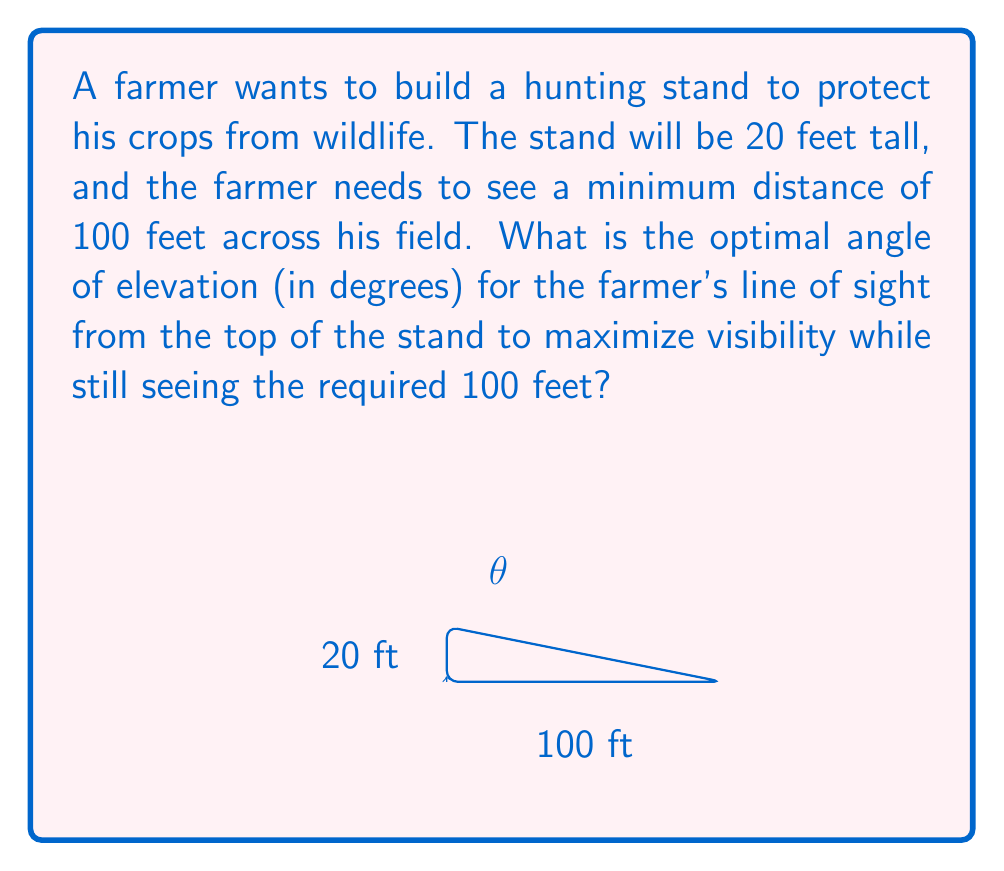Teach me how to tackle this problem. Let's approach this step-by-step:

1) First, we need to understand that the optimal angle of elevation will be the one that allows the farmer to see exactly 100 feet away. Any steeper angle would reduce the visible distance.

2) We can model this situation as a right triangle, where:
   - The vertical side is the height of the stand (20 feet)
   - The horizontal side is the distance to be seen (100 feet)
   - The angle we're looking for is the one between the horizontal and the line of sight

3) We can use the tangent function to find this angle. In a right triangle:

   $\tan(\theta) = \frac{\text{opposite}}{\text{adjacent}} = \frac{\text{height of stand}}{\text{distance to be seen}}$

4) Plugging in our values:

   $\tan(\theta) = \frac{20}{100} = \frac{1}{5} = 0.2$

5) To find $\theta$, we need to use the inverse tangent (arctan or $\tan^{-1}$):

   $\theta = \tan^{-1}(0.2)$

6) Using a calculator or trigonometric tables:

   $\theta \approx 11.3099325$ degrees

7) Rounding to two decimal places for practical use:

   $\theta \approx 11.31$ degrees

This angle will allow the farmer to see exactly 100 feet away from the base of the stand, maximizing visibility while meeting the minimum distance requirement.
Answer: $11.31°$ 